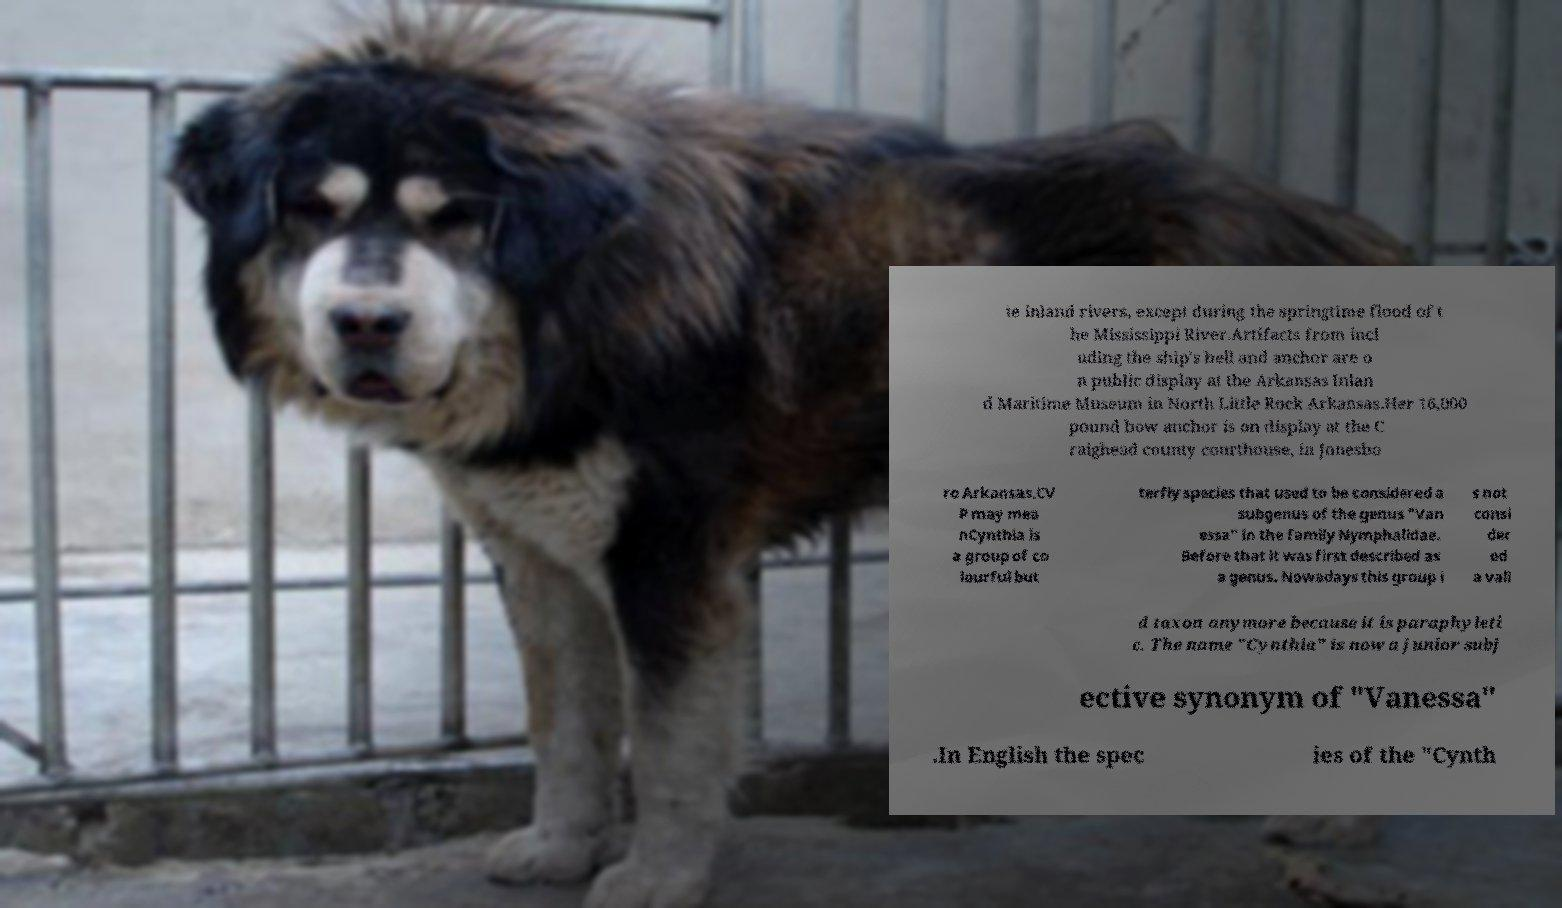Please read and relay the text visible in this image. What does it say? te inland rivers, except during the springtime flood of t he Mississippi River.Artifacts from incl uding the ship's bell and anchor are o n public display at the Arkansas Inlan d Maritime Museum in North Little Rock Arkansas.Her 16,000 pound bow anchor is on display at the C raighead county courthouse, in Jonesbo ro Arkansas.CV P may mea nCynthia is a group of co lourful but terfly species that used to be considered a subgenus of the genus "Van essa" in the family Nymphalidae. Before that it was first described as a genus. Nowadays this group i s not consi der ed a vali d taxon anymore because it is paraphyleti c. The name "Cynthia" is now a junior subj ective synonym of "Vanessa" .In English the spec ies of the "Cynth 